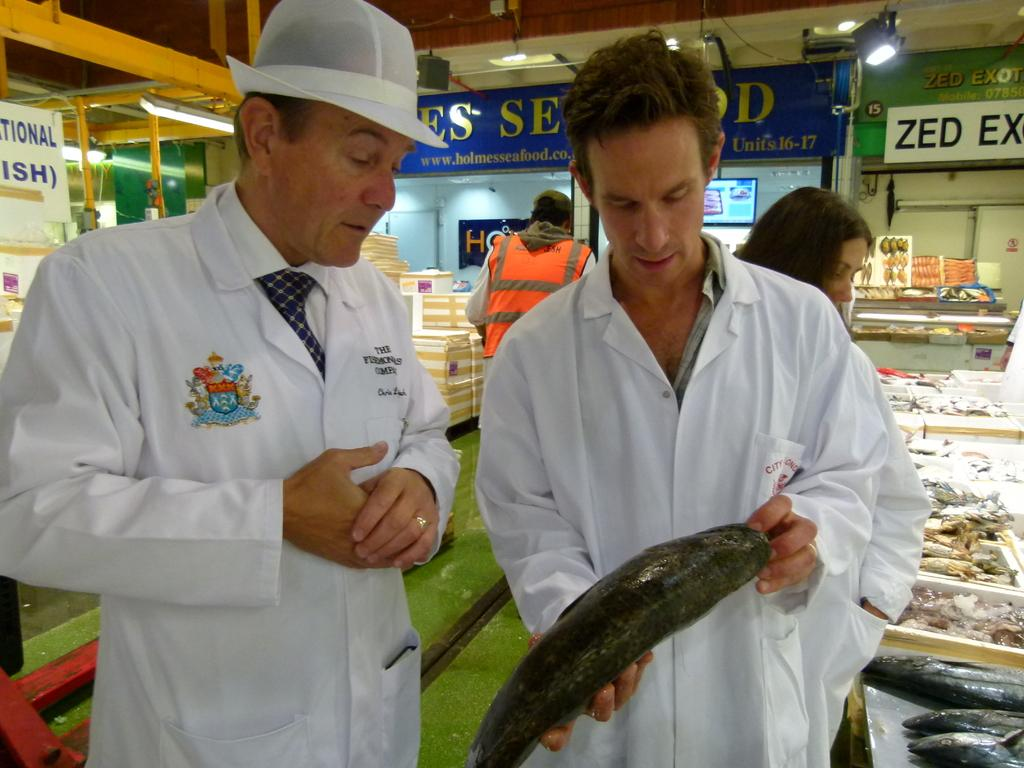<image>
Share a concise interpretation of the image provided. Two men are holding and looking at a fish near Holmes Seafood. 